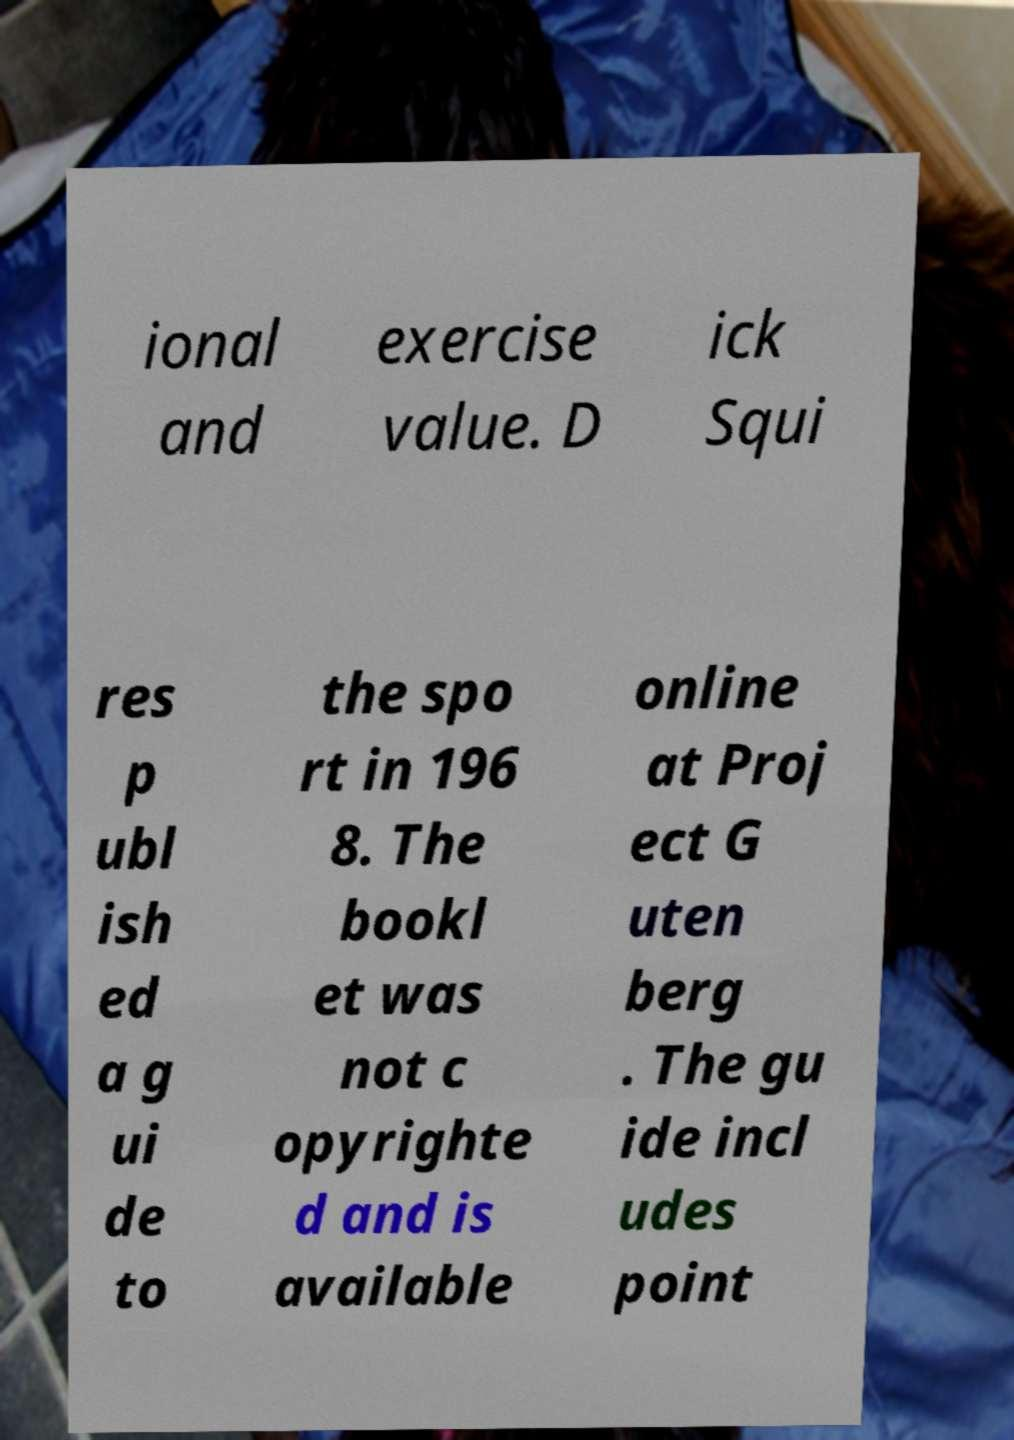I need the written content from this picture converted into text. Can you do that? ional and exercise value. D ick Squi res p ubl ish ed a g ui de to the spo rt in 196 8. The bookl et was not c opyrighte d and is available online at Proj ect G uten berg . The gu ide incl udes point 